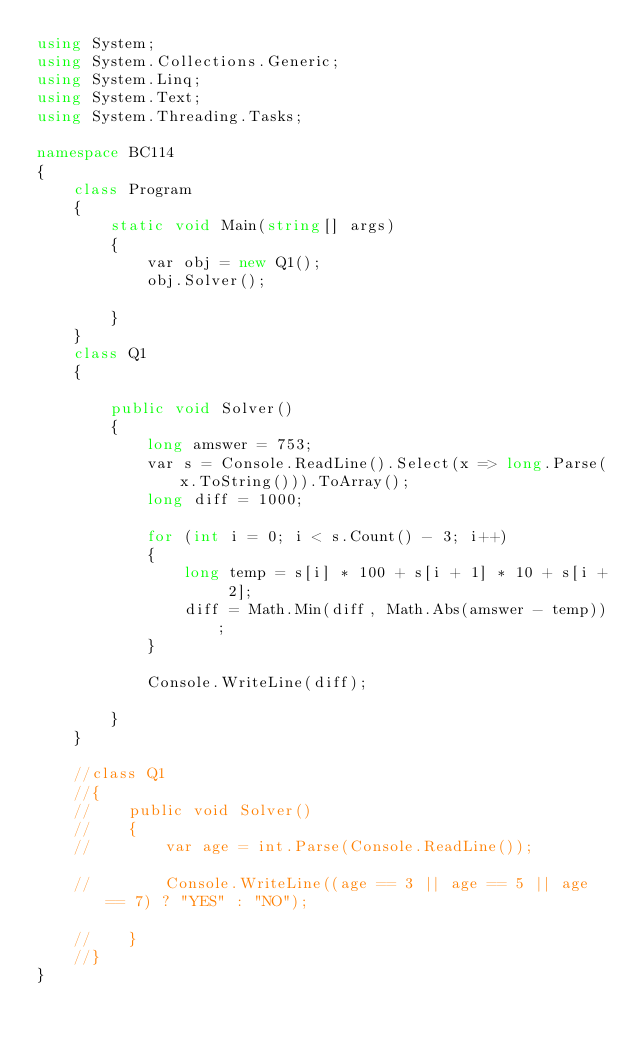<code> <loc_0><loc_0><loc_500><loc_500><_C#_>using System;
using System.Collections.Generic;
using System.Linq;
using System.Text;
using System.Threading.Tasks;

namespace BC114
{
    class Program
    {
        static void Main(string[] args)
        {
            var obj = new Q1();
            obj.Solver();

        }
    }
    class Q1
    {

        public void Solver()
        {
            long amswer = 753;
            var s = Console.ReadLine().Select(x => long.Parse(x.ToString())).ToArray();
            long diff = 1000;

            for (int i = 0; i < s.Count() - 3; i++)
            {
                long temp = s[i] * 100 + s[i + 1] * 10 + s[i + 2];
                diff = Math.Min(diff, Math.Abs(amswer - temp));
            }

            Console.WriteLine(diff);

        }
    }

    //class Q1
    //{
    //    public void Solver()
    //    {
    //        var age = int.Parse(Console.ReadLine());

    //        Console.WriteLine((age == 3 || age == 5 || age == 7) ? "YES" : "NO");

    //    }
    //}
}
</code> 